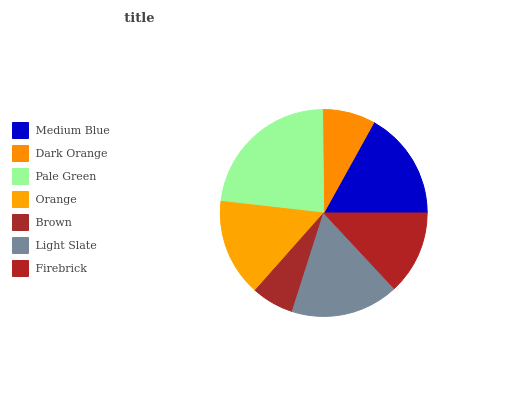Is Brown the minimum?
Answer yes or no. Yes. Is Pale Green the maximum?
Answer yes or no. Yes. Is Dark Orange the minimum?
Answer yes or no. No. Is Dark Orange the maximum?
Answer yes or no. No. Is Medium Blue greater than Dark Orange?
Answer yes or no. Yes. Is Dark Orange less than Medium Blue?
Answer yes or no. Yes. Is Dark Orange greater than Medium Blue?
Answer yes or no. No. Is Medium Blue less than Dark Orange?
Answer yes or no. No. Is Orange the high median?
Answer yes or no. Yes. Is Orange the low median?
Answer yes or no. Yes. Is Brown the high median?
Answer yes or no. No. Is Firebrick the low median?
Answer yes or no. No. 